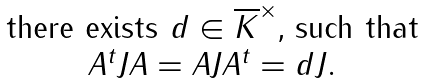<formula> <loc_0><loc_0><loc_500><loc_500>\begin{matrix} \text {there exists $d\in \overline{K}^{\times}$, such that} \\ \text {$A^{t} JA=AJA^{t}=dJ$} . \end{matrix}</formula> 